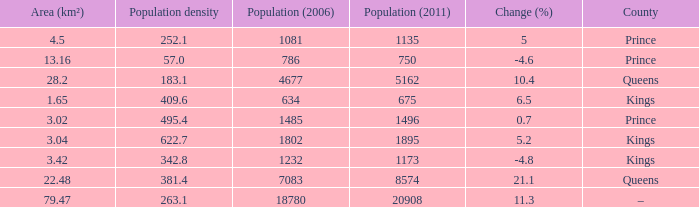What is the Population density that has a Change (%) higher than 10.4, and a Population (2011) less than 8574, in the County of Queens? None. 